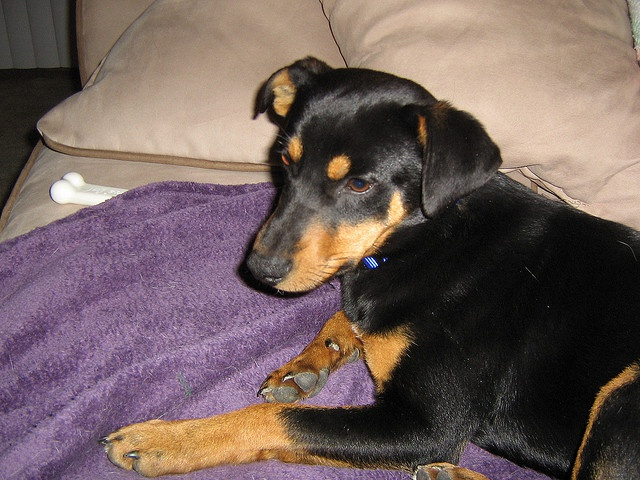Describe the objects in this image and their specific colors. I can see bed in black, darkgray, purple, gray, and tan tones, dog in black, gray, tan, and olive tones, and couch in black, tan, and gray tones in this image. 